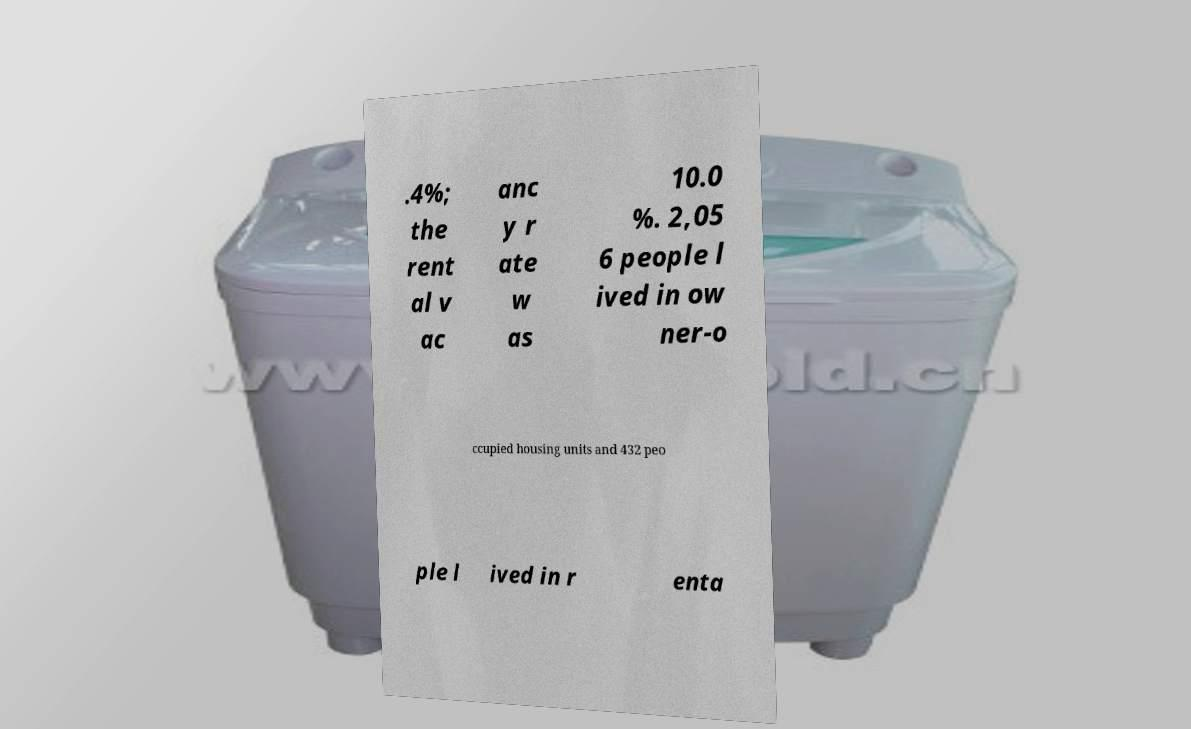For documentation purposes, I need the text within this image transcribed. Could you provide that? .4%; the rent al v ac anc y r ate w as 10.0 %. 2,05 6 people l ived in ow ner-o ccupied housing units and 432 peo ple l ived in r enta 